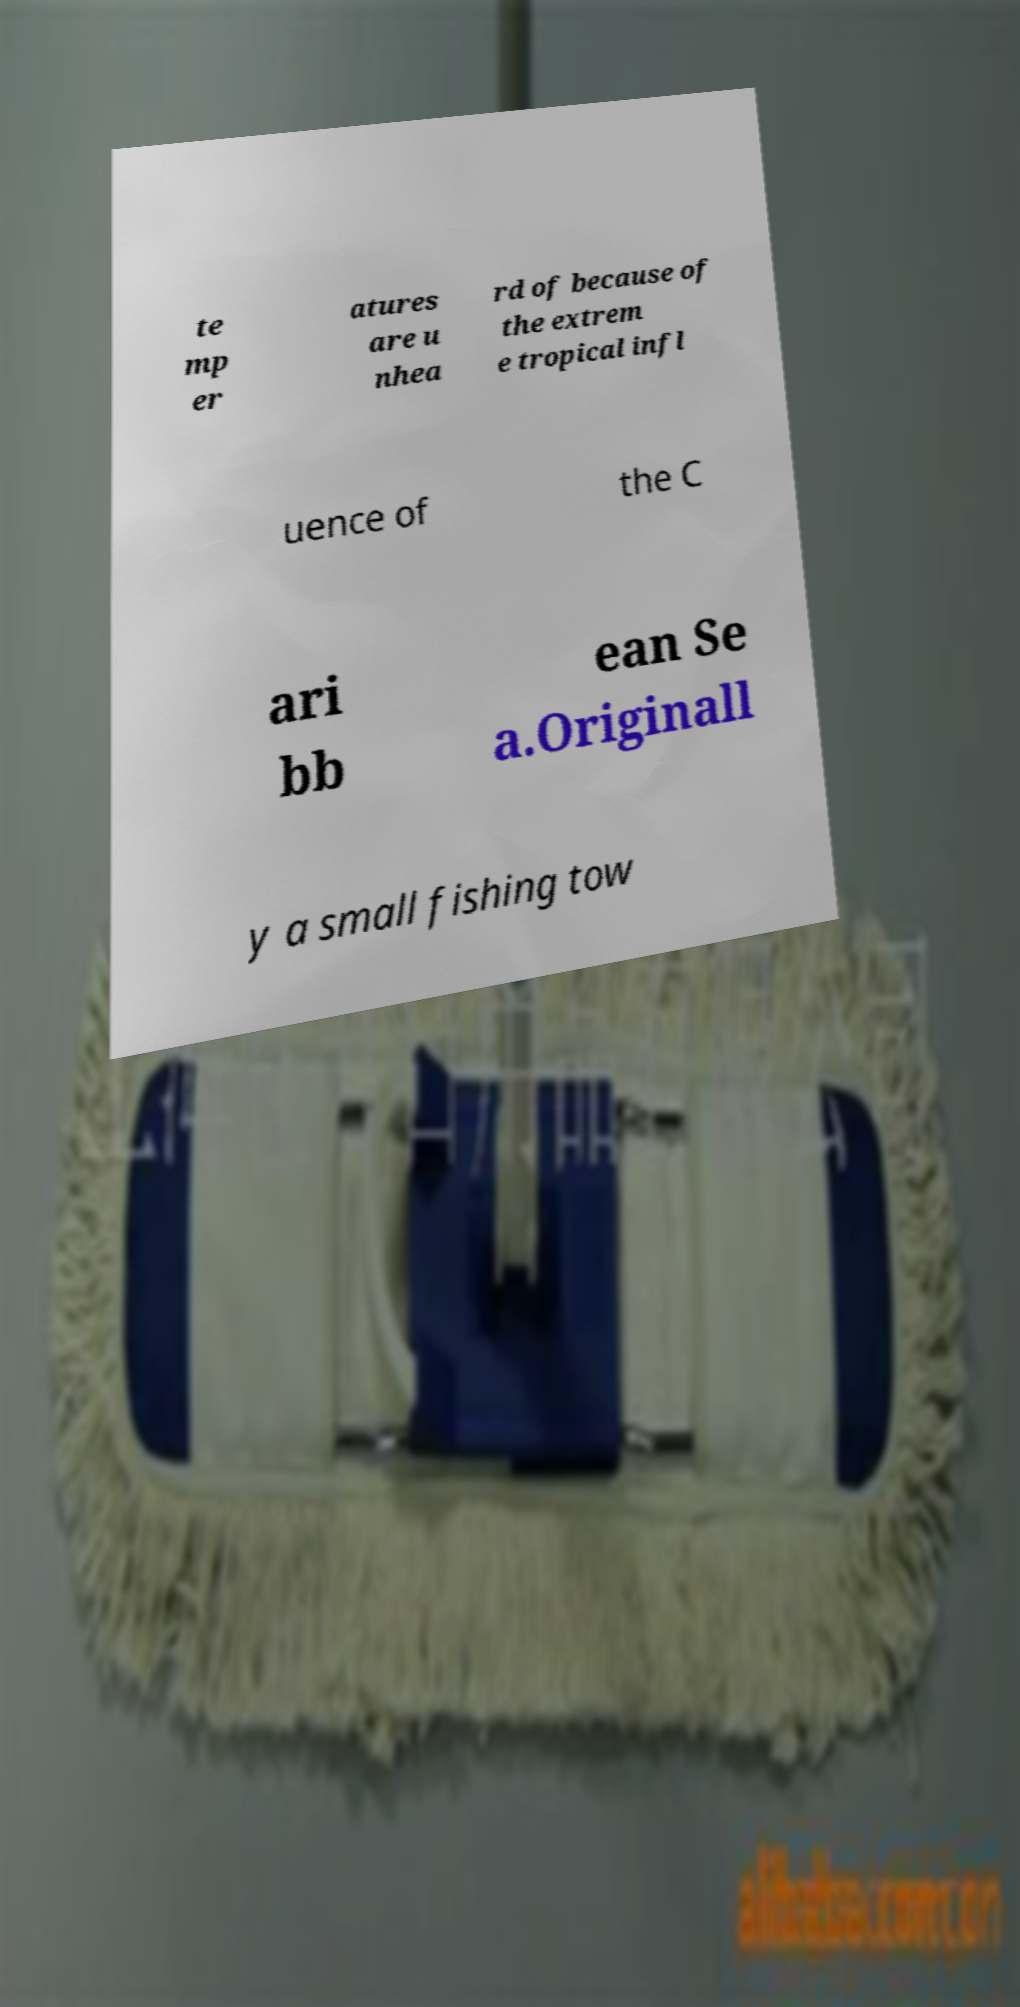Could you assist in decoding the text presented in this image and type it out clearly? te mp er atures are u nhea rd of because of the extrem e tropical infl uence of the C ari bb ean Se a.Originall y a small fishing tow 